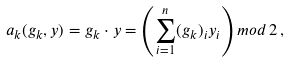Convert formula to latex. <formula><loc_0><loc_0><loc_500><loc_500>a _ { k } ( g _ { k } , y ) = g _ { k } \cdot y = \left ( \sum _ { i = 1 } ^ { n } ( g _ { k } ) _ { i } y _ { i } \right ) m o d \, 2 \, ,</formula> 